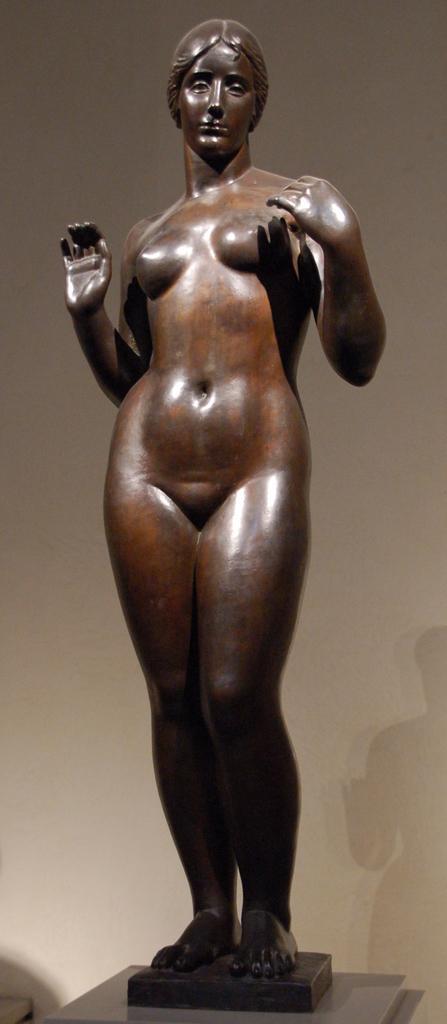Could you give a brief overview of what you see in this image? We can see woman sculpture. Background we can see wall and shadow of the sculpture. 